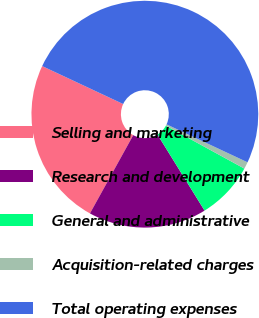<chart> <loc_0><loc_0><loc_500><loc_500><pie_chart><fcel>Selling and marketing<fcel>Research and development<fcel>General and administrative<fcel>Acquisition-related charges<fcel>Total operating expenses<nl><fcel>23.93%<fcel>16.87%<fcel>8.21%<fcel>0.99%<fcel>50.0%<nl></chart> 